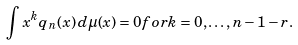Convert formula to latex. <formula><loc_0><loc_0><loc_500><loc_500>\int x ^ { k } q _ { n } ( x ) \, d { \mu } ( x ) = 0 f o r k = 0 , \dots , n - 1 - r .</formula> 